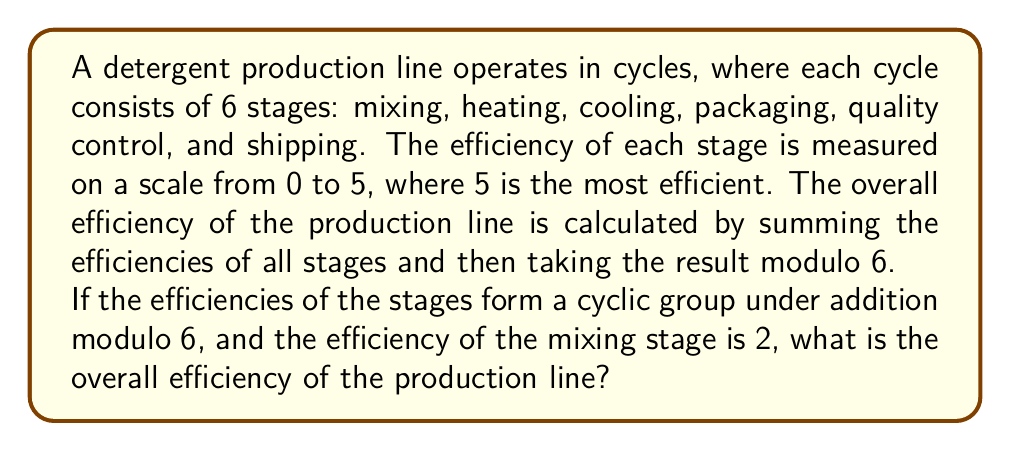Help me with this question. Let's approach this step-by-step:

1) In a cyclic group of order 6 under addition modulo 6, the elements are $\{0, 1, 2, 3, 4, 5\}$.

2) Given that the efficiency of the mixing stage is 2, and the group is cyclic, the efficiencies of the stages must be:

   Mixing: 2
   Heating: 2 + 2 = 4 (mod 6)
   Cooling: 4 + 2 = 0 (mod 6)
   Packaging: 0 + 2 = 2 (mod 6)
   Quality Control: 2 + 2 = 4 (mod 6)
   Shipping: 4 + 2 = 0 (mod 6)

3) To calculate the overall efficiency, we sum these values:

   $$2 + 4 + 0 + 2 + 4 + 0 = 12$$

4) The final step is to take this sum modulo 6:

   $$12 \equiv 0 \pmod{6}$$

Therefore, the overall efficiency of the production line is 0.

This result demonstrates an interesting property of cyclic groups: the sum of all elements in a finite cyclic group is always congruent to 0 modulo the order of the group.
Answer: 0 